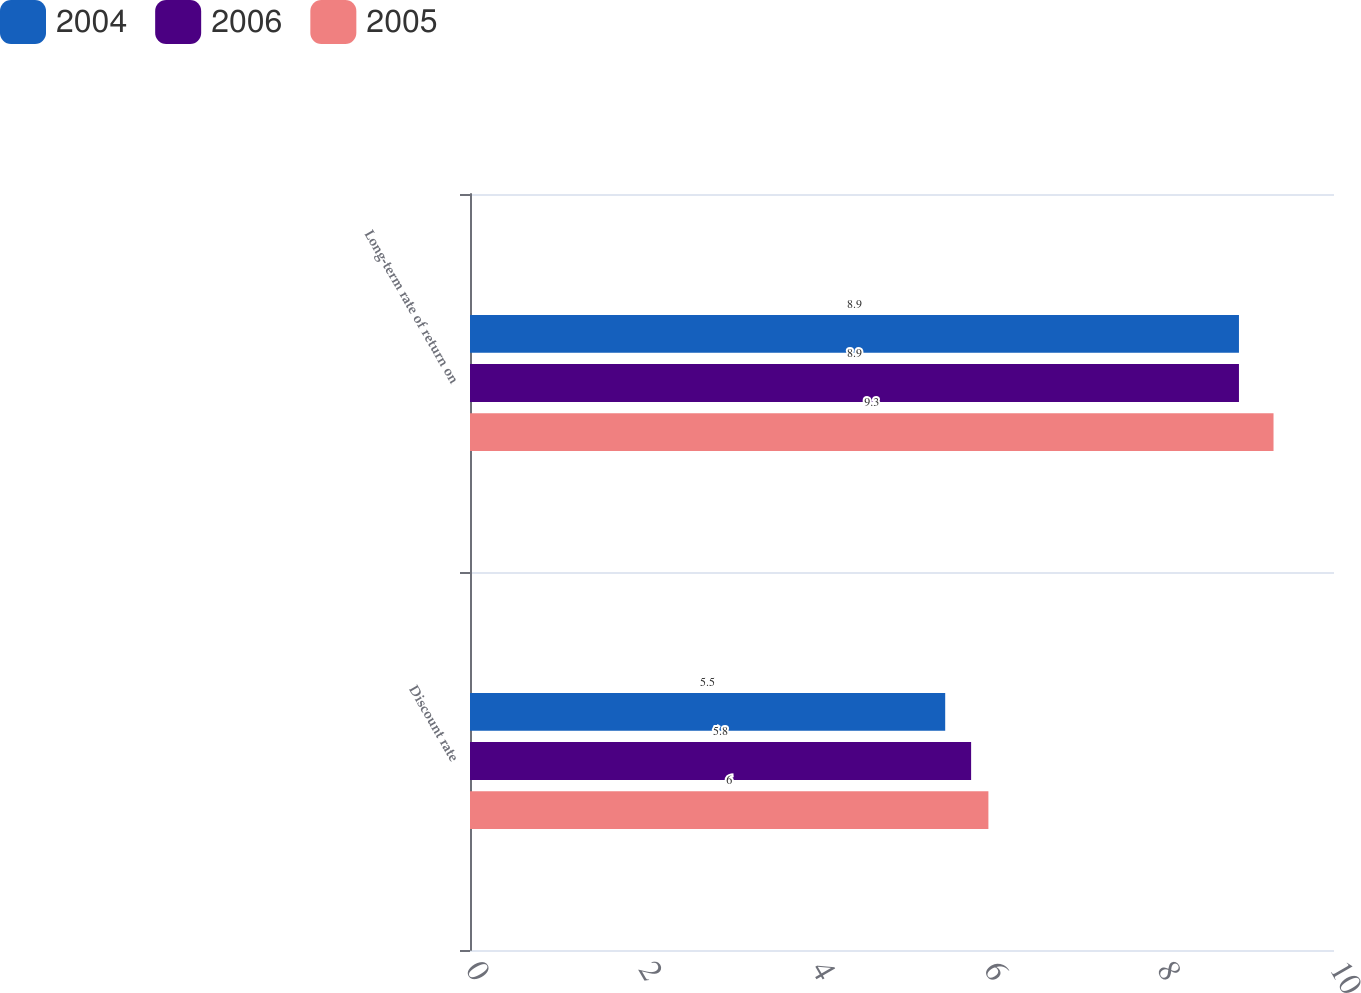Convert chart to OTSL. <chart><loc_0><loc_0><loc_500><loc_500><stacked_bar_chart><ecel><fcel>Discount rate<fcel>Long-term rate of return on<nl><fcel>2004<fcel>5.5<fcel>8.9<nl><fcel>2006<fcel>5.8<fcel>8.9<nl><fcel>2005<fcel>6<fcel>9.3<nl></chart> 